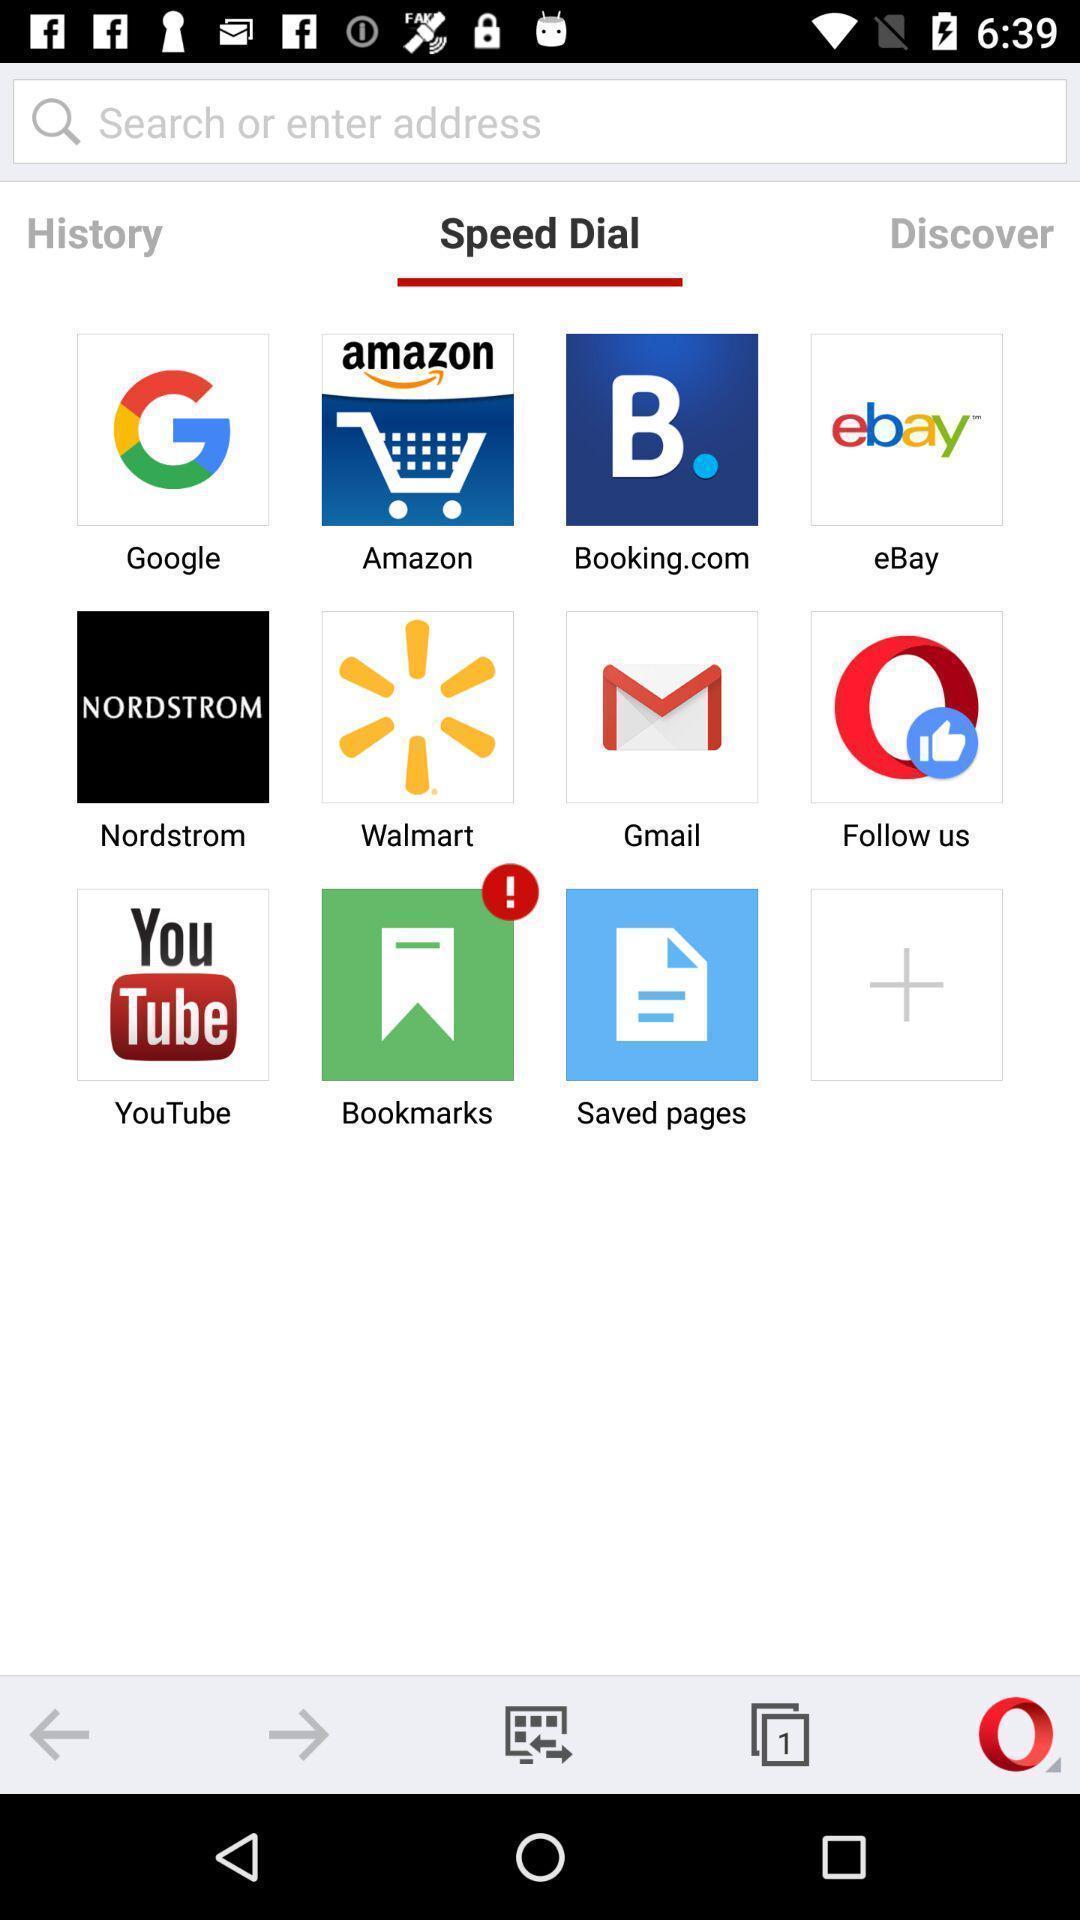Explain the elements present in this screenshot. Page showing lot of apps in a browser. 